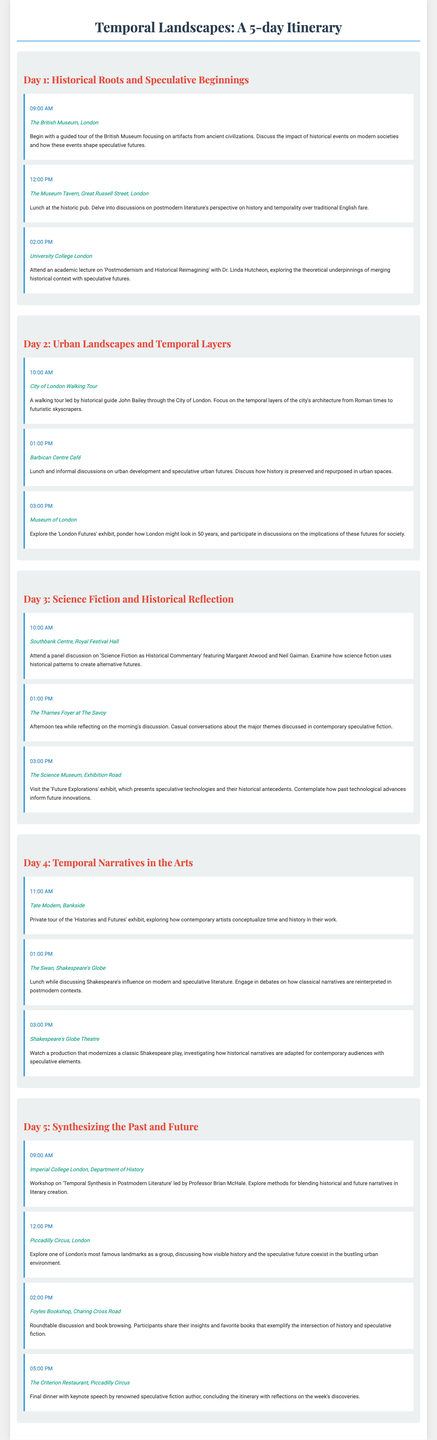what time does the Museum Tavern lunch start? The itinerary mentions the Museum Tavern lunch starting at 12:00 PM.
Answer: 12:00 PM who is the lecturer on Day 1 at University College London? The lecturer mentioned for Day 1 at University College London is Dr. Linda Hutcheon.
Answer: Dr. Linda Hutcheon what location is the final dinner held? The final dinner is held at The Criterion Restaurant, Piccadilly Circus.
Answer: The Criterion Restaurant, Piccadilly Circus how many activities are scheduled for Day 3? Day 3 has three activities listed in the itinerary.
Answer: 3 what exhibit is explored at the Museum of London on Day 2? On Day 2, the 'London Futures' exhibit is explored at the Museum of London.
Answer: 'London Futures' exhibit what topic will the workshop on Day 5 focus on? The workshop on Day 5 will focus on 'Temporal Synthesis in Postmodern Literature.'
Answer: Temporal Synthesis in Postmodern Literature which author gives the keynote speech at the final dinner? The keynote speech at the final dinner is given by a renowned speculative fiction author.
Answer: renowned speculative fiction author what time does the walking tour of the City of London begin? The City of London walking tour begins at 10:00 AM.
Answer: 10:00 AM 